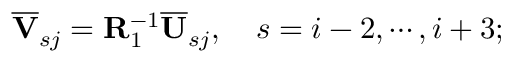<formula> <loc_0><loc_0><loc_500><loc_500>\overline { V } _ { s j } = R _ { 1 } ^ { - 1 } \overline { U } _ { s j } , \quad s = i - 2 , \cdots , i + 3 ;</formula> 